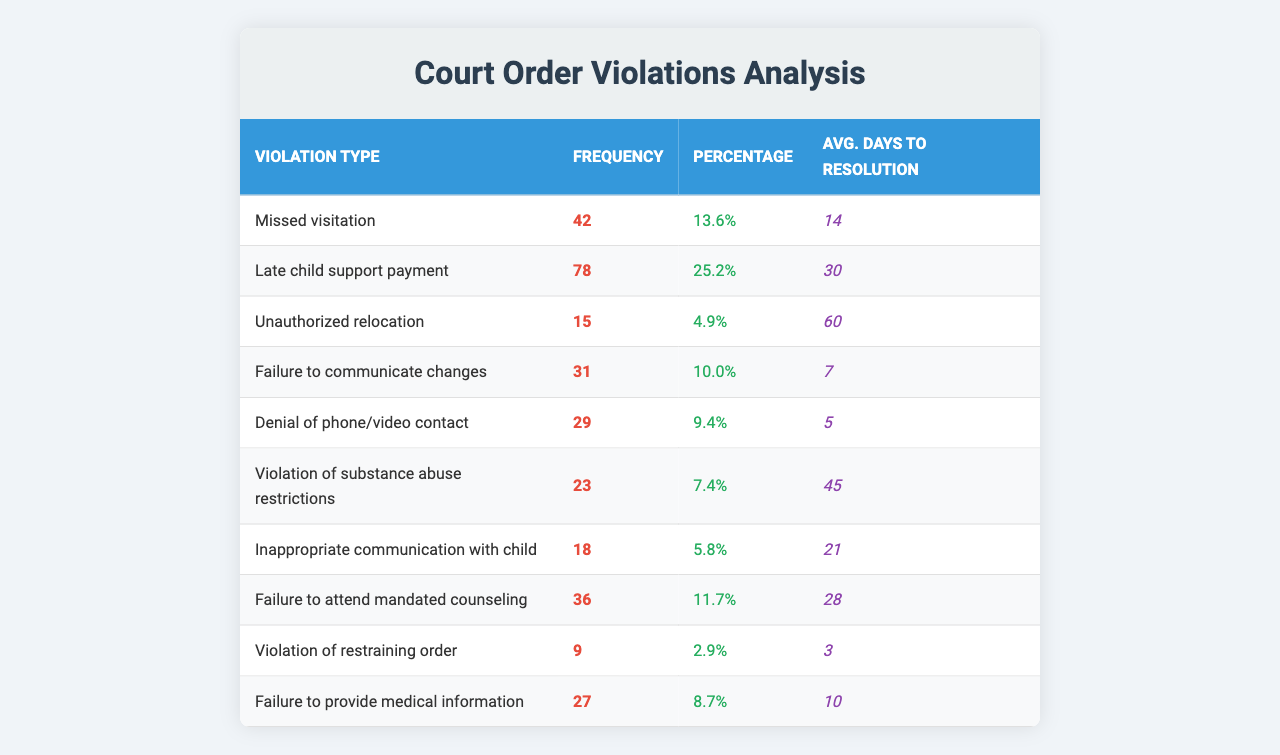What is the violation type with the highest frequency? By examining the frequency column, "Late child support payment" has the highest frequency at 78.
Answer: Late child support payment What is the total frequency of all violations listed? The total frequency is the sum of all individual frequencies: 42 + 78 + 15 + 31 + 29 + 23 + 18 + 36 + 9 + 27 = 378.
Answer: 378 Which violation type corresponds with the minimum average days to resolution? The average days to resolution column indicates that "Failure to provide medical information" has the minimum value of 3 days.
Answer: Failure to provide medical information What percentage of violations are related to "Missed visitation"? The percentage value for "Missed visitation" is explicitly listed as 13.6%.
Answer: 13.6% Is the frequency of "Denied phone/video contact" greater than that of "Violation of restraining order"? By comparing the two, "Denied phone/video contact" has a frequency of 29, while "Violation of restraining order" has a frequency of 9, so the statement is true.
Answer: Yes What is the average days to resolution for the violation type with the second highest frequency? The second highest frequency is for "Missed visitation" with 42 cases, and checking the average days to resolution gives us 14 days for this violation type.
Answer: 14 Calculate the difference in frequency between "Unauthorized relocation" and "Failure to communicate changes". The frequency of "Unauthorized relocation" is 15, and "Failure to communicate changes" is 31, thus the difference is 31 - 15 = 16.
Answer: 16 What is the average percentage of all the violations? To find the average percentage, sum all the percentages (13.6 + 25.2 + 4.9 + 10 + 9.4 + 7.4 + 5.8 + 11.7 + 2.9 + 8.7) = 99.6, then divide by the number of violation types, which is 10: 99.6/10 = 9.96%.
Answer: 9.96% Which violation type has a higher frequency: "Failure to attend mandated counseling" or "Inappropriate communication with child"? "Failure to attend mandated counseling" has a frequency of 36, while "Inappropriate communication with child" has a frequency of 18, so the first violation type has a higher frequency.
Answer: Failure to attend mandated counseling How many violation types have frequencies below 20? By looking at the frequency column, "Unauthorized relocation" (15), "Violation of restraining order" (9), and "Inappropriate communication with child" (18) are below 20, so there are 3 violation types.
Answer: 3 